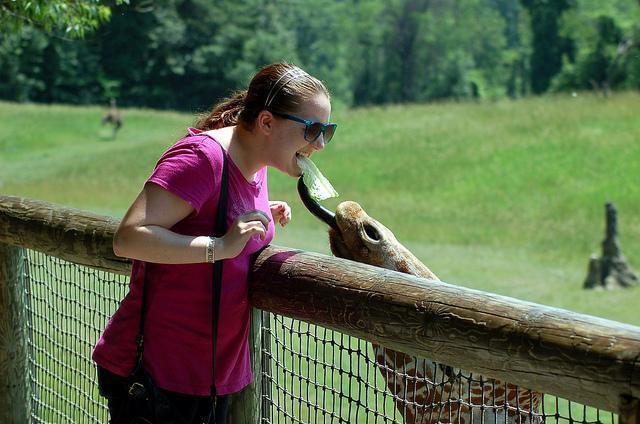How many red frisbees can you see?
Give a very brief answer. 0. 